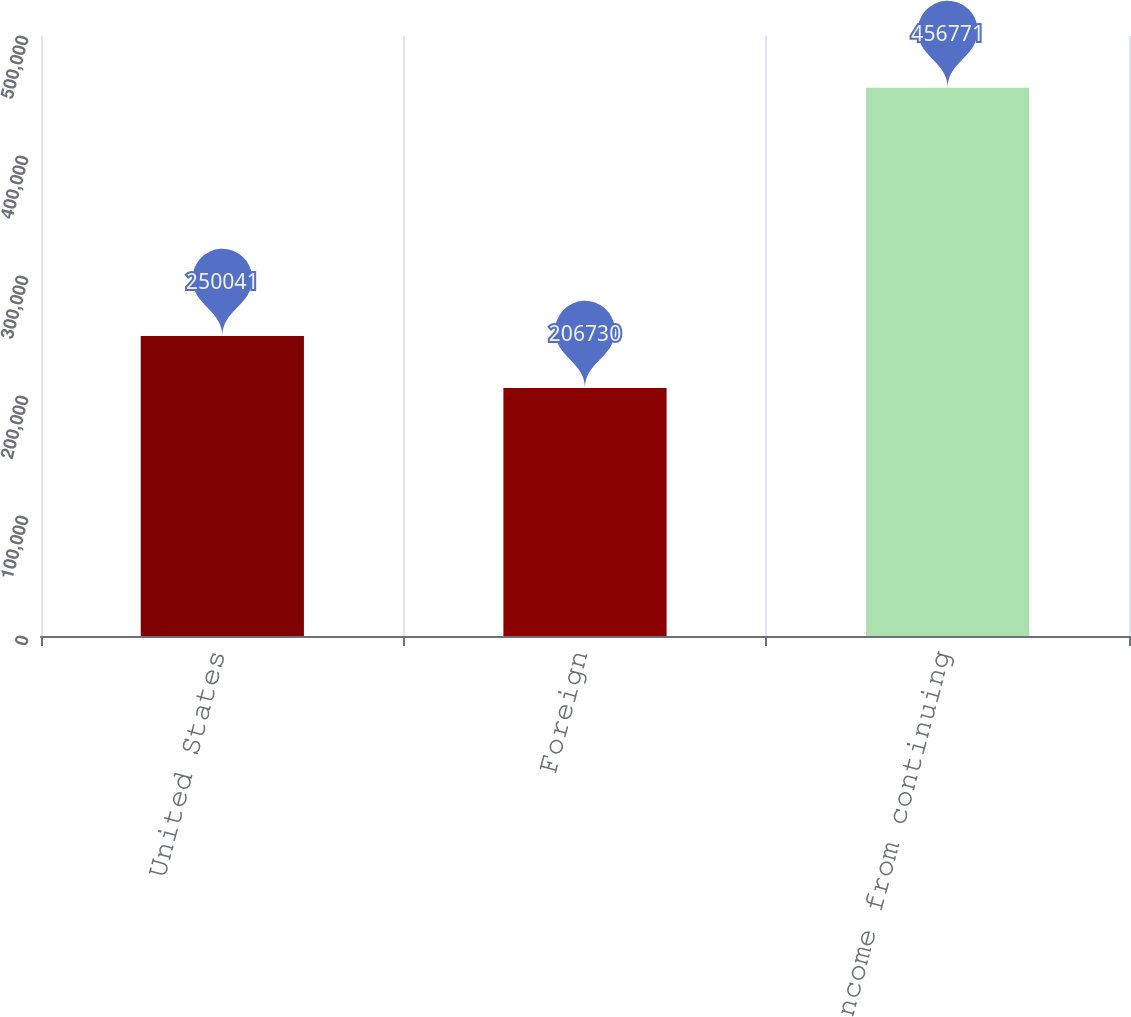Convert chart to OTSL. <chart><loc_0><loc_0><loc_500><loc_500><bar_chart><fcel>United States<fcel>Foreign<fcel>Total income from continuing<nl><fcel>250041<fcel>206730<fcel>456771<nl></chart> 